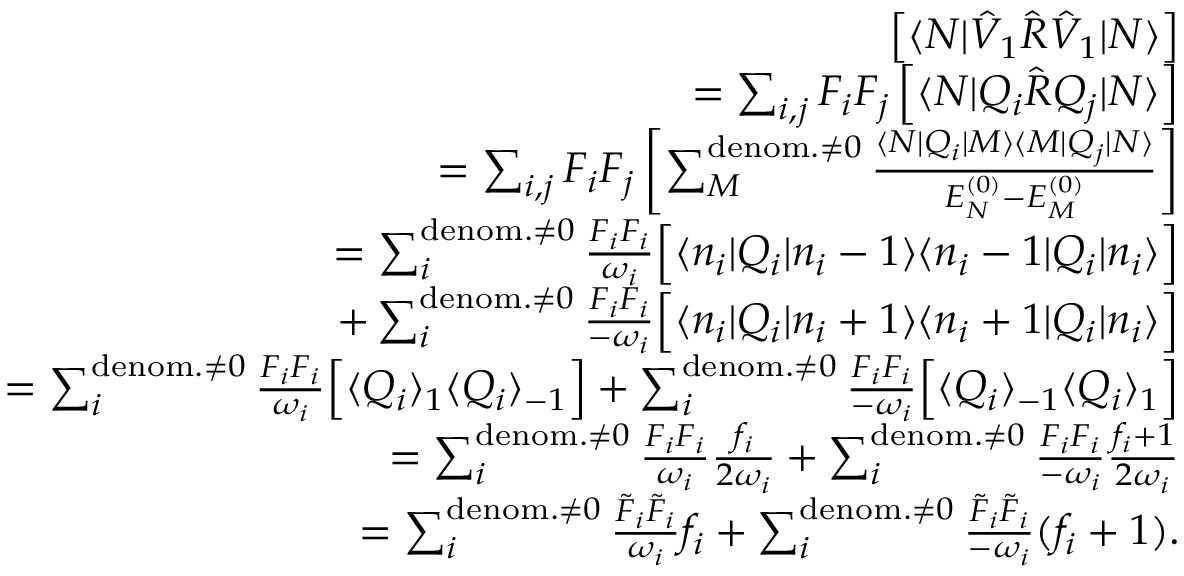Convert formula to latex. <formula><loc_0><loc_0><loc_500><loc_500>\begin{array} { r l r } & { \left [ \langle N | \hat { V } _ { 1 } \hat { R } \hat { V } _ { 1 } | N \rangle \right ] } \\ & { = \sum _ { i , j } F _ { i } F _ { j } \left [ \langle N | Q _ { i } \hat { R } Q _ { j } | N \rangle \right ] } \\ & { = \sum _ { i , j } F _ { i } F _ { j } \left [ \sum _ { M } ^ { d e n o m . \neq 0 } \frac { \langle N | Q _ { i } | M \rangle \langle M | Q _ { j } | N \rangle } { E _ { N } ^ { ( 0 ) } - E _ { M } ^ { ( 0 ) } } \right ] } \\ & { = \sum _ { i } ^ { d e n o m . \neq 0 } \frac { F _ { i } F _ { i } } { \omega _ { i } } \left [ \langle n _ { i } | Q _ { i } | n _ { i } - 1 \rangle \langle n _ { i } - 1 | Q _ { i } | n _ { i } \rangle \right ] } \\ & { + \sum _ { i } ^ { d e n o m . \neq 0 } \frac { F _ { i } F _ { i } } { - \omega _ { i } } \left [ \langle n _ { i } | Q _ { i } | n _ { i } + 1 \rangle \langle n _ { i } + 1 | Q _ { i } | n _ { i } \rangle \right ] } \\ & { = \sum _ { i } ^ { d e n o m . \neq 0 } \frac { F _ { i } F _ { i } } { \omega _ { i } } \left [ \langle Q _ { i } \rangle _ { 1 } \langle Q _ { i } \rangle _ { - 1 } \right ] + \sum _ { i } ^ { d e n o m . \neq 0 } \frac { F _ { i } F _ { i } } { - \omega _ { i } } \left [ \langle Q _ { i } \rangle _ { - 1 } \langle Q _ { i } \rangle _ { 1 } \right ] } \\ & { = \sum _ { i } ^ { d e n o m . \neq 0 } \frac { F _ { i } F _ { i } } { \omega _ { i } } \frac { f _ { i } } { 2 \omega _ { i } } + \sum _ { i } ^ { d e n o m . \neq 0 } \frac { F _ { i } F _ { i } } { - \omega _ { i } } \frac { f _ { i } + 1 } { 2 \omega _ { i } } } \\ & { = \sum _ { i } ^ { d e n o m . \neq 0 } \frac { \tilde { F } _ { i } \tilde { F } _ { i } } { \omega _ { i } } { f _ { i } } + \sum _ { i } ^ { d e n o m . \neq 0 } \frac { \tilde { F } _ { i } \tilde { F } _ { i } } { - \omega _ { i } } { ( f _ { i } + 1 ) } . } \end{array}</formula> 